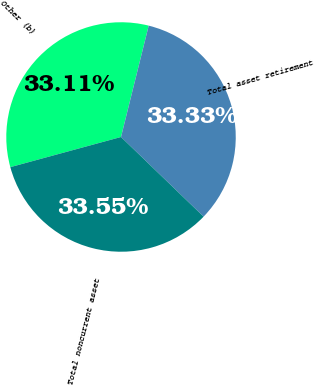Convert chart to OTSL. <chart><loc_0><loc_0><loc_500><loc_500><pie_chart><fcel>Other (b)<fcel>Total asset retirement<fcel>Total noncurrent asset<nl><fcel>33.11%<fcel>33.33%<fcel>33.55%<nl></chart> 